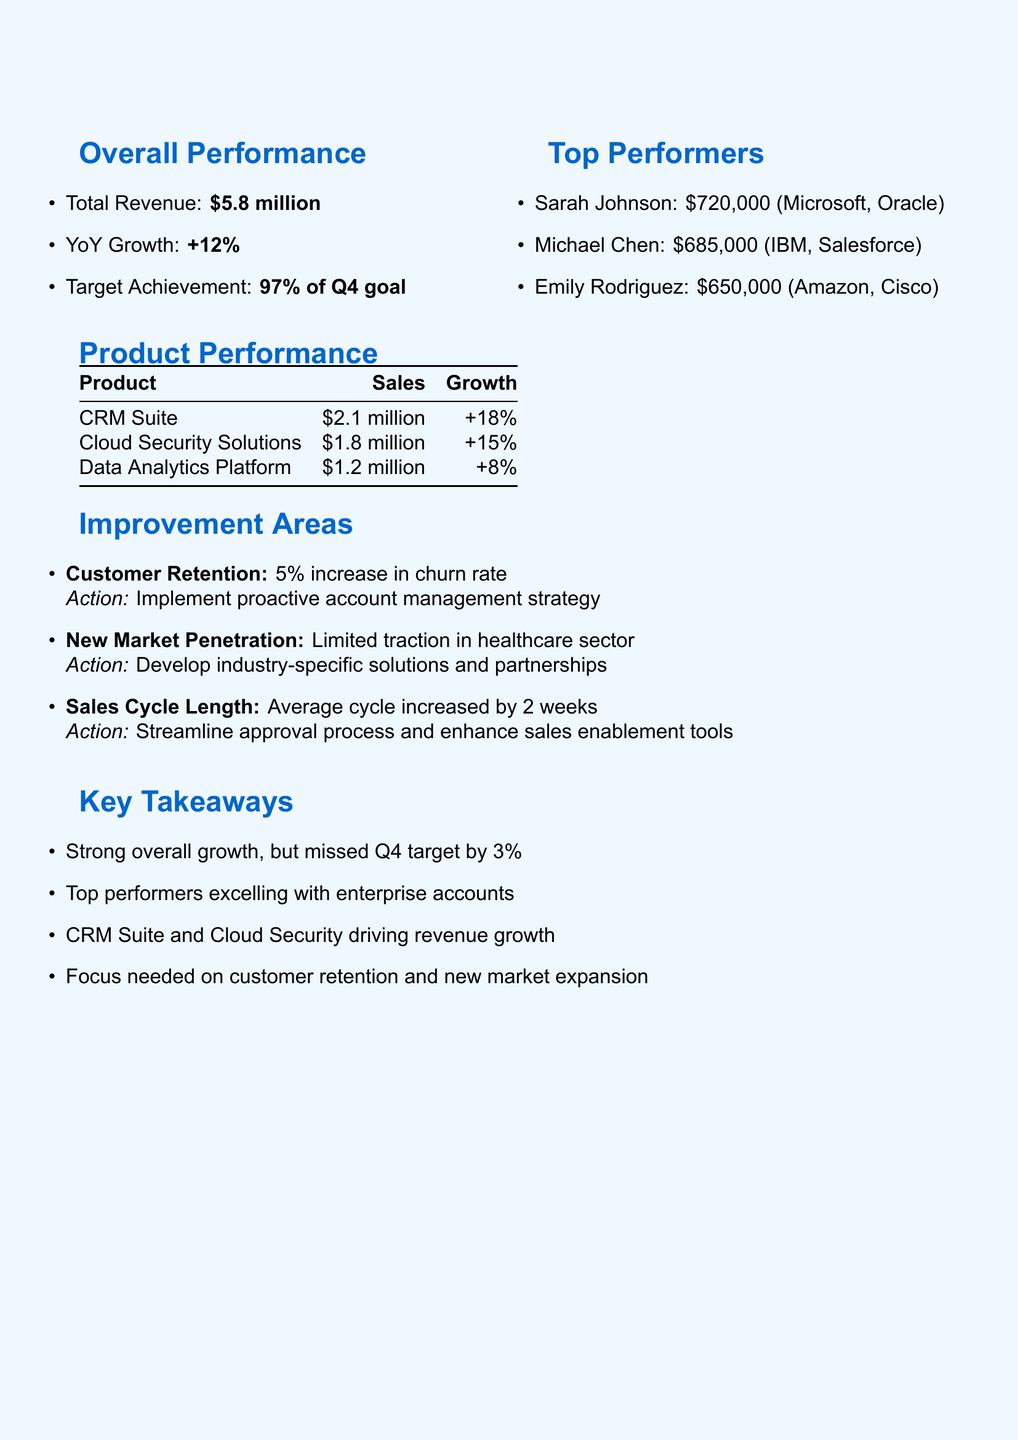what is the total revenue? The total revenue is stated in the overall performance section of the document as $5.8 million.
Answer: $5.8 million who are the top performers? The top performers listed in the document are Sarah Johnson, Michael Chen, and Emily Rodriguez.
Answer: Sarah Johnson, Michael Chen, Emily Rodriguez what percentage of the Q4 goal was achieved? The document specifies that 97% of the Q4 goal was achieved.
Answer: 97% which product had the highest sales? The product performance table shows that the CRM Suite had the highest sales at $2.1 million.
Answer: CRM Suite what is the key issue in customer retention? The document indicates that the key issue in customer retention is a 5% increase in churn rate.
Answer: 5% increase in churn rate how many weeks did the sales cycle length increase? It is noted in the improvement areas that the average sales cycle increased by 2 weeks.
Answer: 2 weeks what action is suggested for new market penetration? The document suggests to develop industry-specific solutions and partnerships for new market penetration.
Answer: Develop industry-specific solutions and partnerships what is the year-over-year growth? The overall performance section states that the year-over-year growth is +12%.
Answer: +12% what is one of the key takeaways from the analysis? The document summarizes several key takeaways, one of which is strong overall growth but missed the Q4 target by 3%.
Answer: Strong overall growth, but missed Q4 target by 3% 